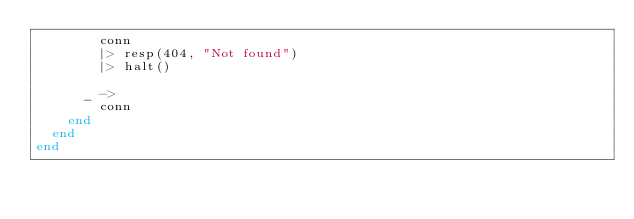<code> <loc_0><loc_0><loc_500><loc_500><_Elixir_>        conn
        |> resp(404, "Not found")
        |> halt()

      _ ->
        conn
    end
  end
end
</code> 